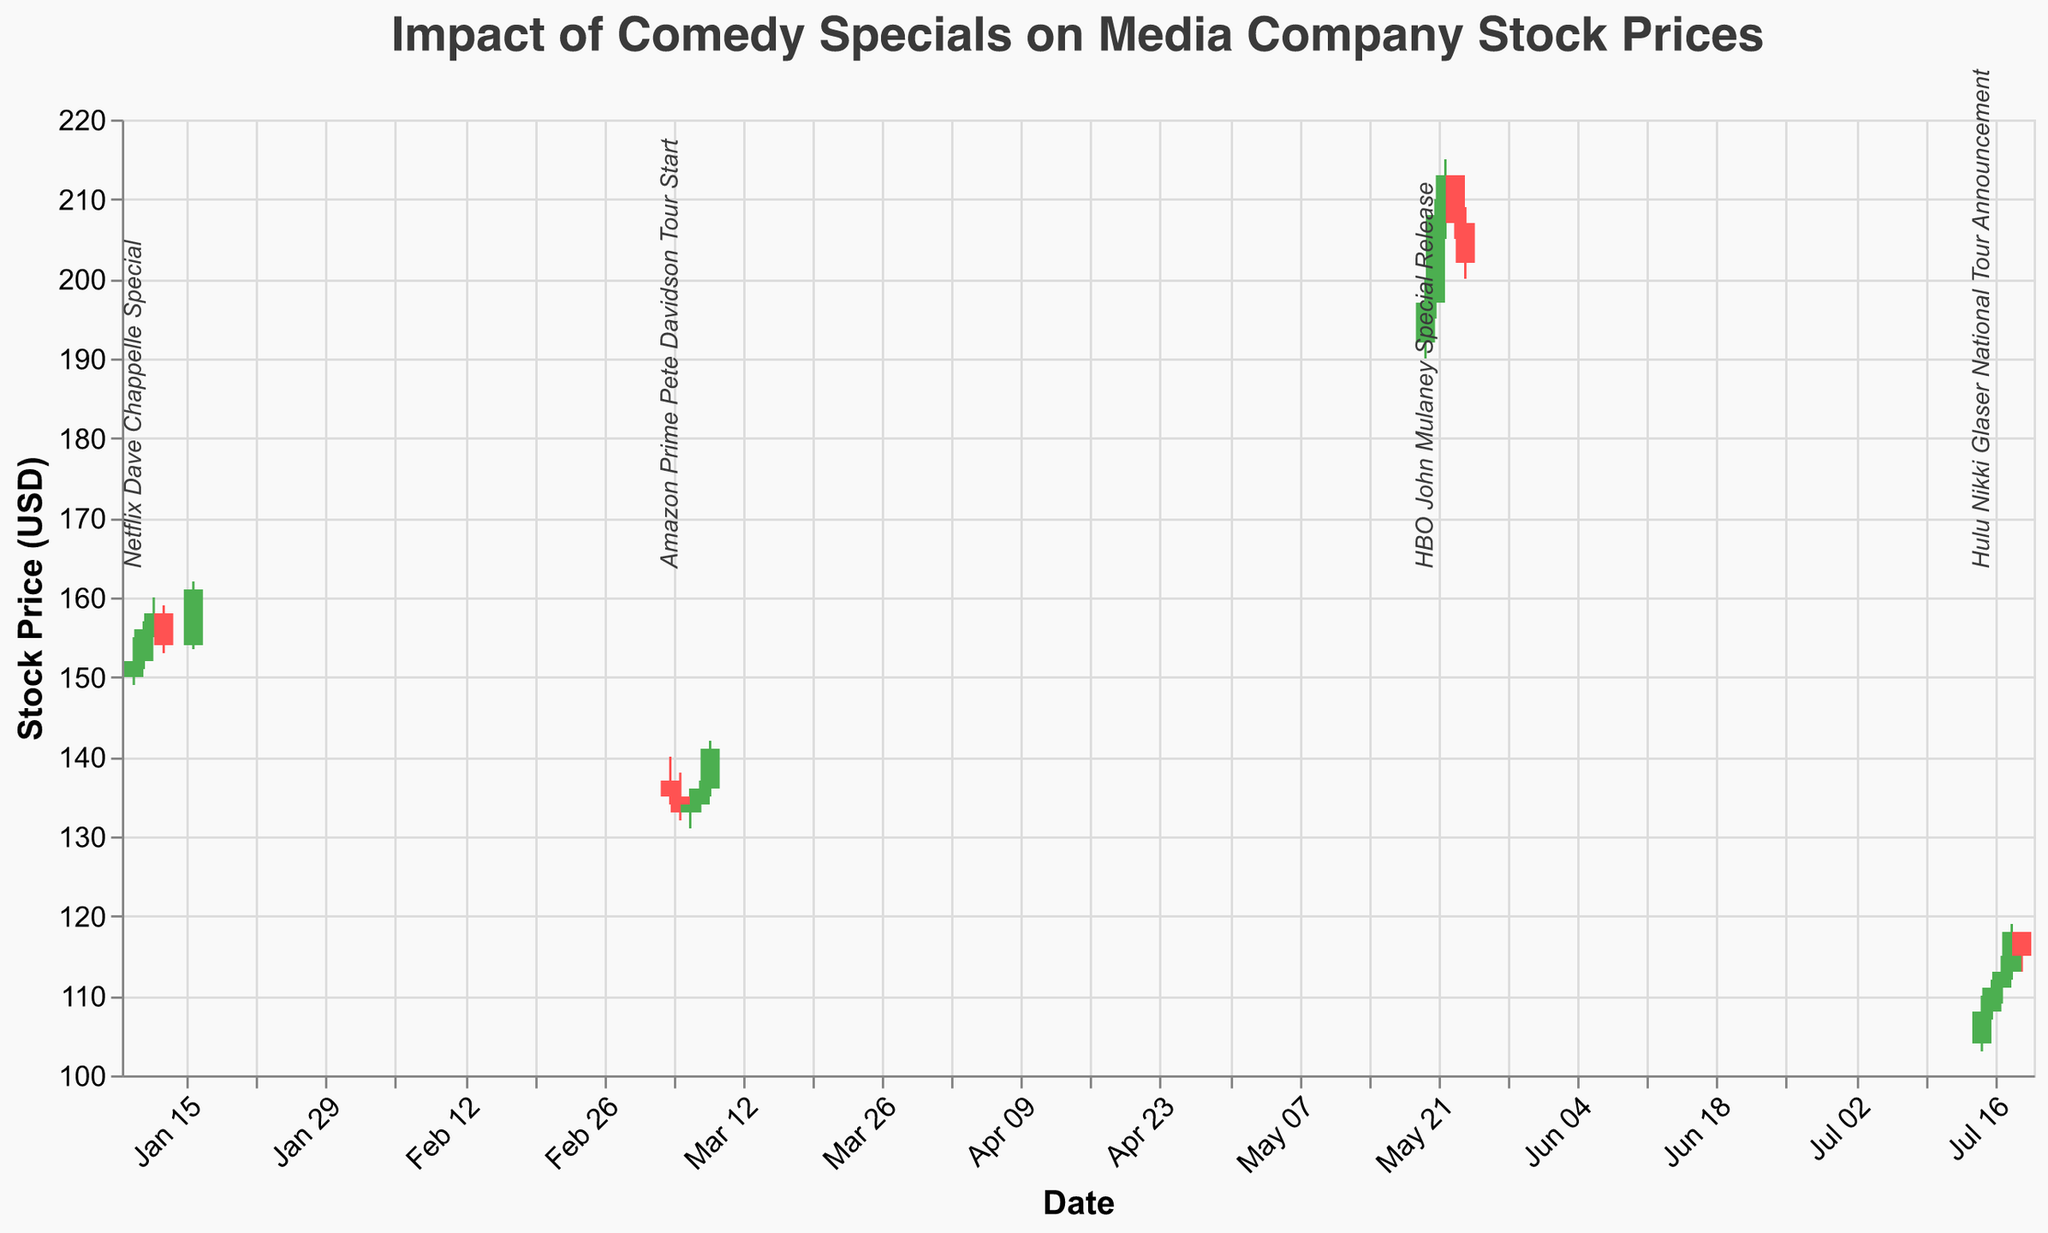When did the stock price first increase after the Netflix Dave Chappelle Special? After the Netflix Dave Chappelle Special on January 10, 2023, the stock price increased on January 11, 2023. The closing price rose from 152.00 to 156.00.
Answer: January 11, 2023 How did the stock price change immediately after the Amazon Prime Pete Davidson Tour Start? The stock price decreased the day after the Amazon Prime Pete Davidson Tour Start on March 5, 2023, from a close of 135.00 to a close of 133.00 on March 6, 2023.
Answer: It decreased What was the highest closing stock price following the HBO John Mulaney Special Release? The HBO John Mulaney Special was released on May 20, 2023, and the highest closing price after that event was 213.00 on May 22, 2023.
Answer: 213.00 What is the overall trend in stock price following the Hulu Nikki Glaser National Tour Announcement? Following the Hulu Nikki Glaser National Tour Announcement on July 15, 2023, the stock price shows an upward trend, increasing from 108.00 on July 15 to 118.00 on July 18, before dropping slightly to 115.00 on July 19.
Answer: Upward Compare the stock price changes of the two events in January and March. Which shows a more significant increase in stock prices, and by how much? In January (Netflix Dave Chappelle Special), the price increased from 152.00 to 161.00 (9.00 increase). In March (Amazon Prime Pete Davidson Tour Start), the stock increased from 135.00 on March 5 to 141.00 on March 9 (6.00 increase). The Netflix event shows a more significant increase of 3.00 more.
Answer: Netflix event, 3.00 What was the stock price movement range on July 18, 2023? On July 18, 2023, the stock price moved between a low of 112.00 and a high of 119.00, so the range is 119.00 - 112.00 = 7.00.
Answer: 7.00 Which event resulted in the highest volume of stock trades and how many trades were there? The highest volume of trades occurred on May 22, 2023, following the HBO John Mulaney Special Release, with a volume of 7200000.
Answer: HBO John Mulaney Special Release, 7200000 Between the Netflix Dave Chappelle Special and the HBO John Mulaney Special Release, which caused a more substantial immediate stock price change? The Netflix Dave Chappelle Special saw a price increase from 152.00 to 156.00 (4.00 increase), while the HBO John Mulaney Special release saw a price increase from 197.00 to 208.00 (11.00 increase) the day after. The HBO event caused a more substantial immediate change.
Answer: HBO John Mulaney Special Release 